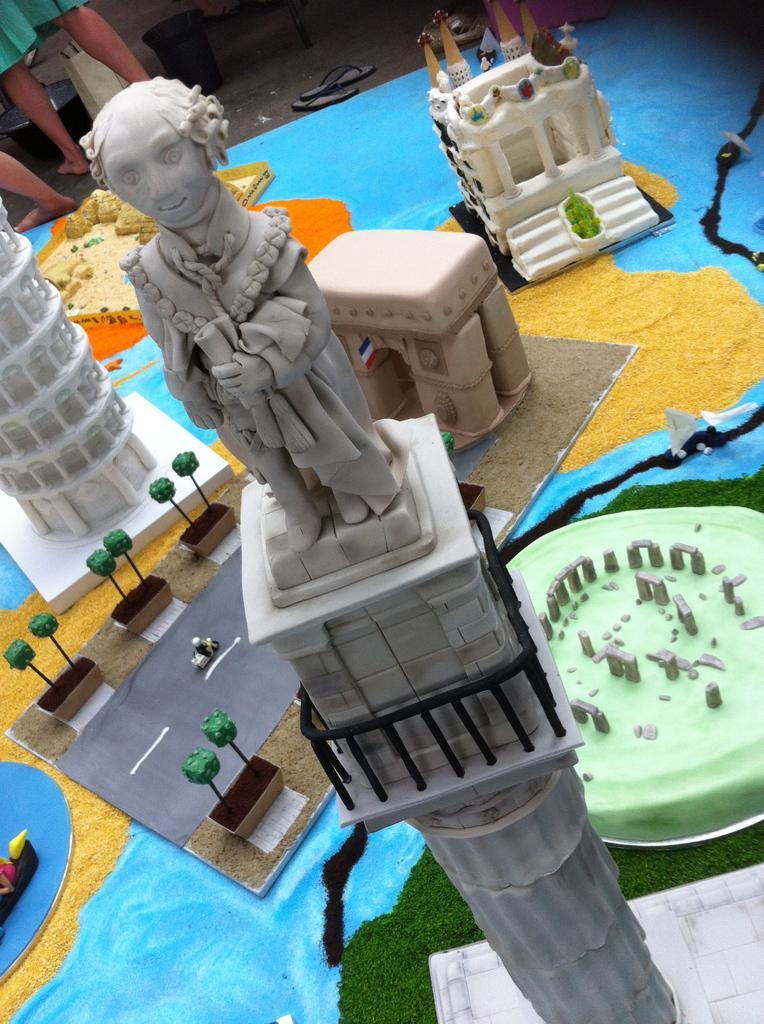Describe this image in one or two sentences. In this picture we can observe a statue on the tower. This is a sample of a project. We can observe road. On the left side there is a person standing. In the background we can observe sandals on the floor. 